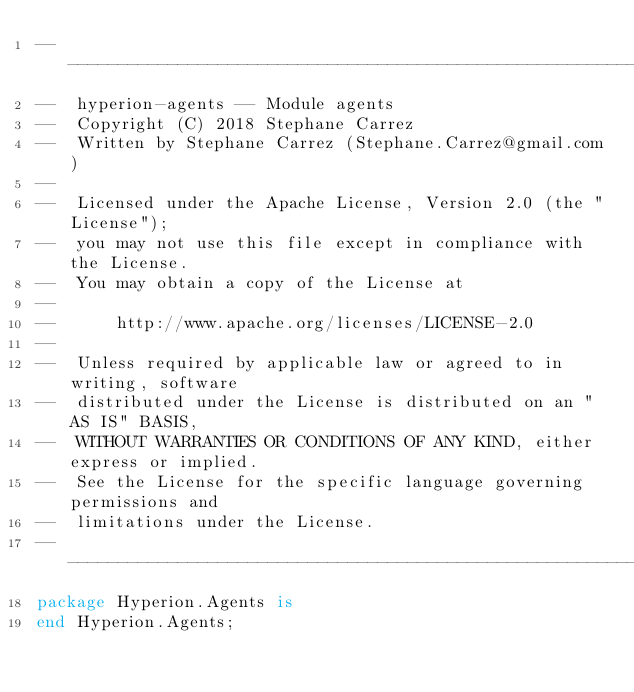<code> <loc_0><loc_0><loc_500><loc_500><_Ada_>-----------------------------------------------------------------------
--  hyperion-agents -- Module agents
--  Copyright (C) 2018 Stephane Carrez
--  Written by Stephane Carrez (Stephane.Carrez@gmail.com)
--
--  Licensed under the Apache License, Version 2.0 (the "License");
--  you may not use this file except in compliance with the License.
--  You may obtain a copy of the License at
--
--      http://www.apache.org/licenses/LICENSE-2.0
--
--  Unless required by applicable law or agreed to in writing, software
--  distributed under the License is distributed on an "AS IS" BASIS,
--  WITHOUT WARRANTIES OR CONDITIONS OF ANY KIND, either express or implied.
--  See the License for the specific language governing permissions and
--  limitations under the License.
-----------------------------------------------------------------------
package Hyperion.Agents is
end Hyperion.Agents;
</code> 